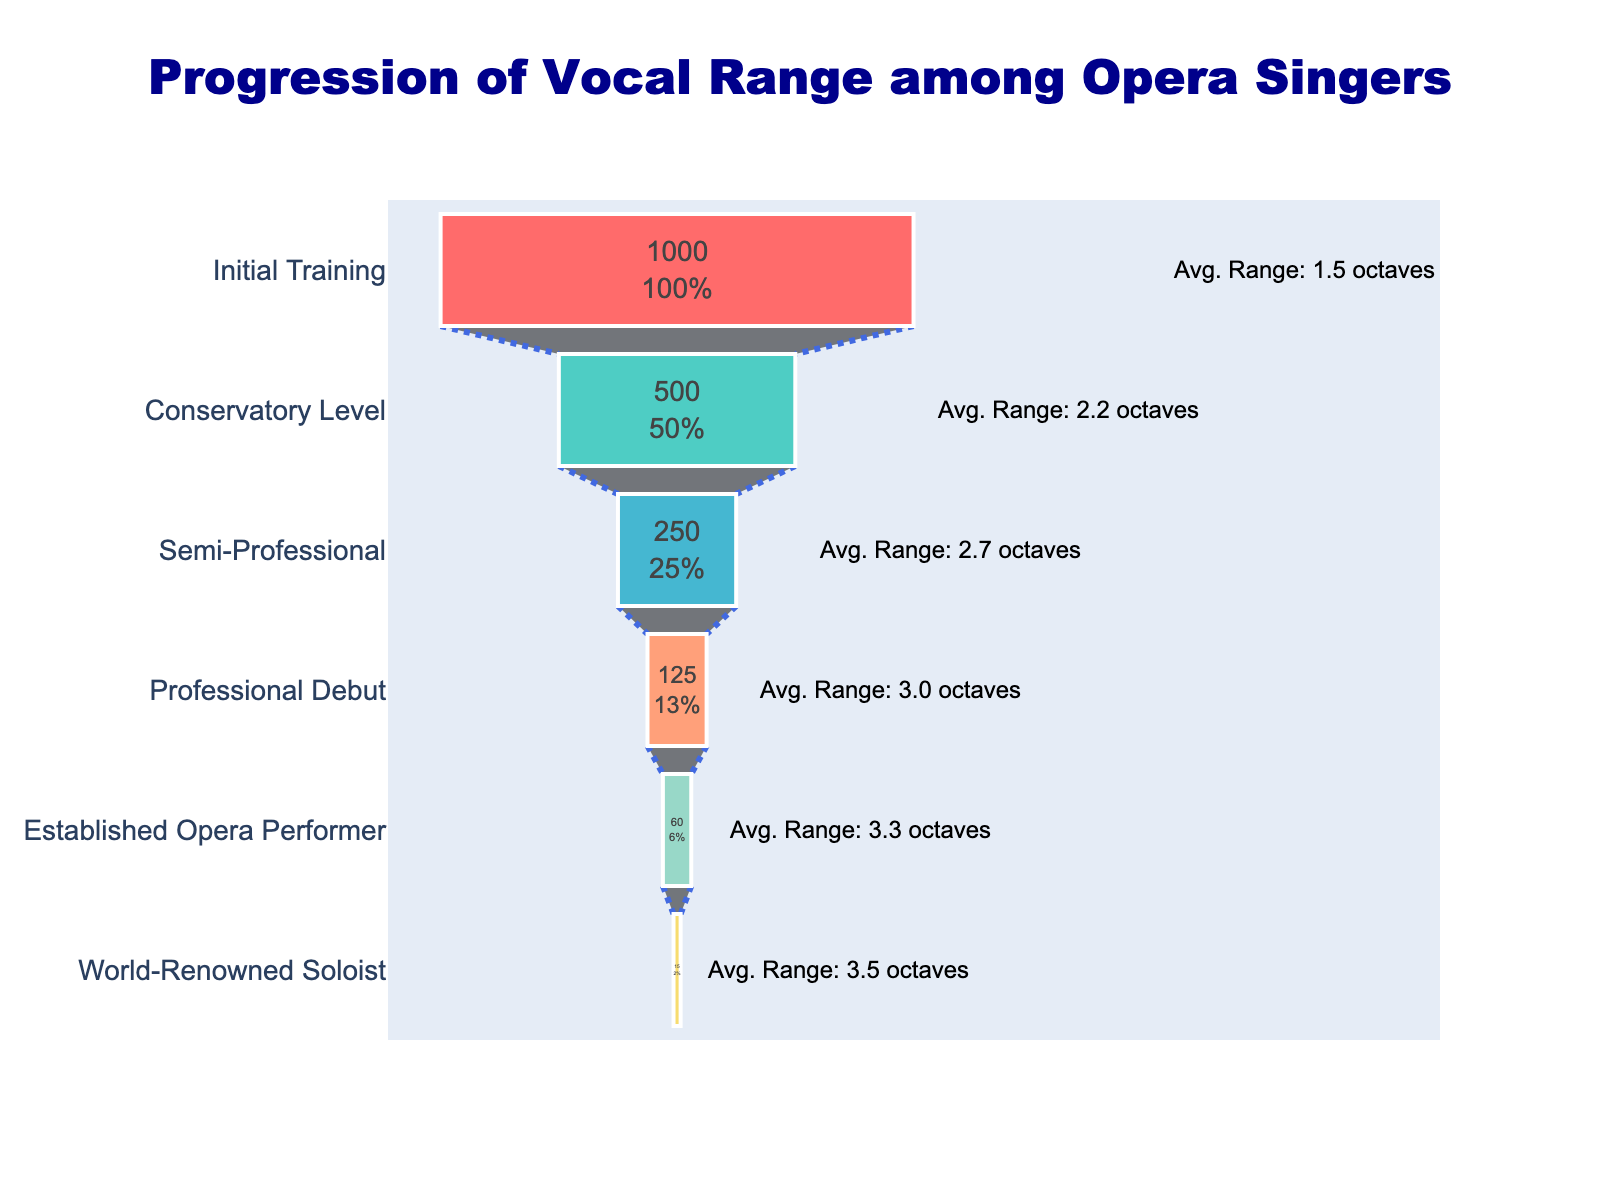what is the title of the figure? The title of the figure is prominently displayed at the top of the chart in large, bold font. It reads "Progression of Vocal Range among Opera Singers".
Answer: Progression of Vocal Range among Opera Singers what stage has the highest number of singers? The stage with the highest number of singers is marked by the widest part of the funnel chart. The initial training stage has 1000 singers.
Answer: Initial Training what is the average vocal range (in octaves) for semi-professional singers? Looking at the label next to the semi-professional stage, the annotation shows the average vocal range for semi-professional singers is 2.7 octaves.
Answer: 2.7 octaves how many singers make it to the world-renowned soloist stage? The narrowest part of the funnel chart, denoting the world-renowned soloist stage, is annotated with the number of singers which is 15.
Answer: 15 how does the number of singers change from initial training to conservatory level? At the initial training stage, there are 1000 singers. At the conservatory level, there are 500 singers. The change is calculated by subtracting the two numbers: 1000 - 500 = 500. The number of singers decreases by 500.
Answer: Decreases by 500 what is the progression of average vocal range from initial training to professional debut? At the initial training stage, the average vocal range is 1.5 octaves. It increases to 3.0 octaves at the professional debut stage. The difference is calculated by subtracting the initial average from the final average: 3.0 - 1.5 = 1.5 octaves. The average vocal range increases by 1.5 octaves.
Answer: Increases by 1.5 octaves at which stage is the average vocal range closest to 3 octaves? Observing the annotations of each stage, the average vocal range closest to 3 octaves is at the professional debut stage, which has an average vocal range of 3.0 octaves.
Answer: Professional Debut what percentage of singers progress from conservatory level to semi-professional stage? At the conservatory level, there are 500 singers. At the semi-professional stage, there are 250 singers. The percentage of singers progressing can be calculated as (250 / 500) * 100% = 50%.
Answer: 50% which stage shows the most significant drop in the number of singers? To determine the most significant drop, we compare the differences in the number of singers between consecutive stages. The largest absolute difference is between the initial training stage (1000) and the conservatory level (500), with a drop of 500 singers.
Answer: Initial Training to Conservatory Level 